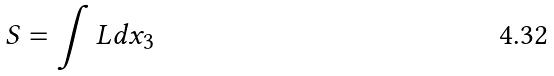Convert formula to latex. <formula><loc_0><loc_0><loc_500><loc_500>S = \int L d x _ { 3 }</formula> 